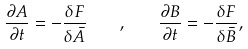<formula> <loc_0><loc_0><loc_500><loc_500>\frac { \partial A } { \partial t } = - \frac { \delta F } { \delta \bar { A } } \quad , \quad \frac { \partial B } { \partial t } = - \frac { \delta F } { \delta \bar { B } } ,</formula> 